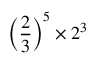<formula> <loc_0><loc_0><loc_500><loc_500>\left ( { \frac { 2 } { 3 } } \right ) ^ { 5 } \times 2 ^ { 3 }</formula> 